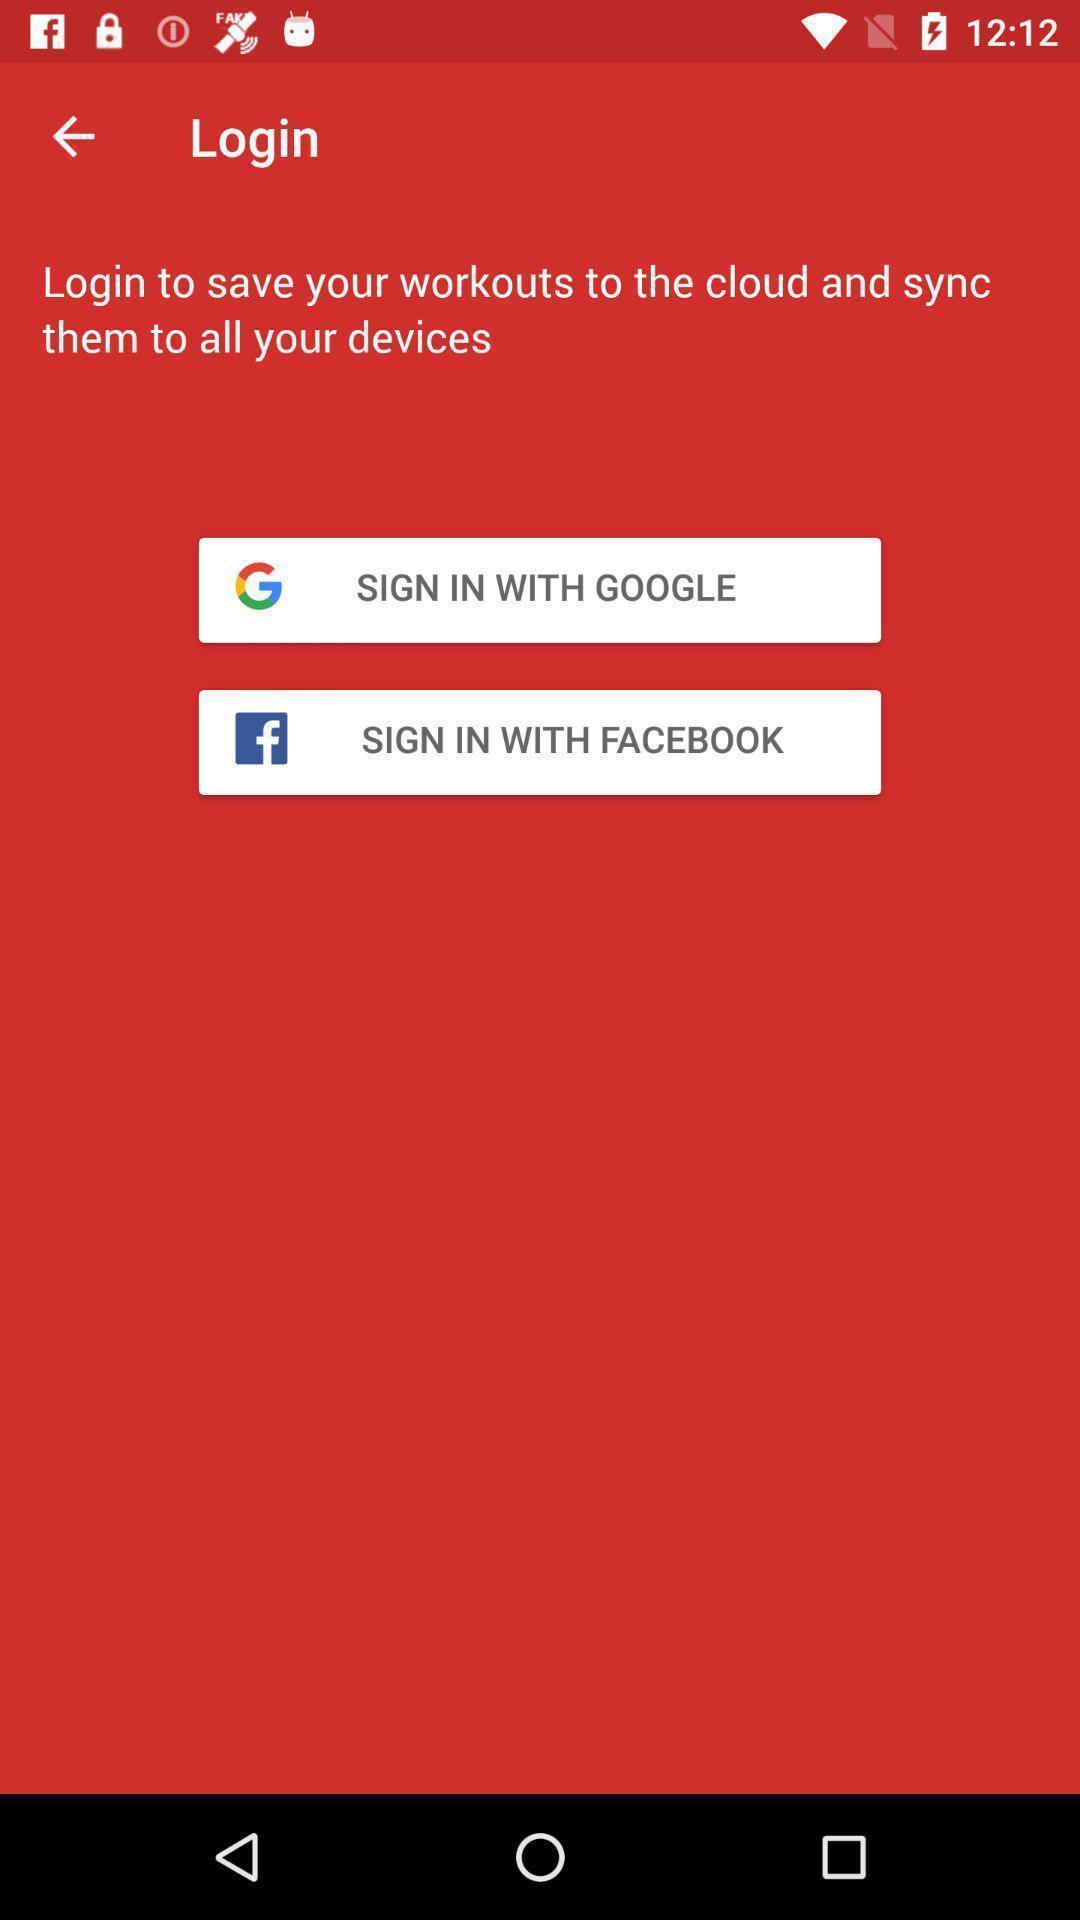Explain the elements present in this screenshot. Sign in page of a fitness app. 